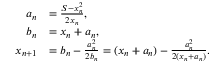Convert formula to latex. <formula><loc_0><loc_0><loc_500><loc_500>{ \begin{array} { r l } { a _ { n } } & { = { \frac { S - x _ { n } ^ { 2 } } { 2 x _ { n } } } , } \\ { b _ { n } } & { = x _ { n } + a _ { n } , } \\ { x _ { n + 1 } } & { = b _ { n } - { \frac { a _ { n } ^ { 2 } } { 2 b _ { n } } } = ( x _ { n } + a _ { n } ) - { \frac { a _ { n } ^ { 2 } } { 2 ( x _ { n } + a _ { n } ) } } . } \end{array} }</formula> 